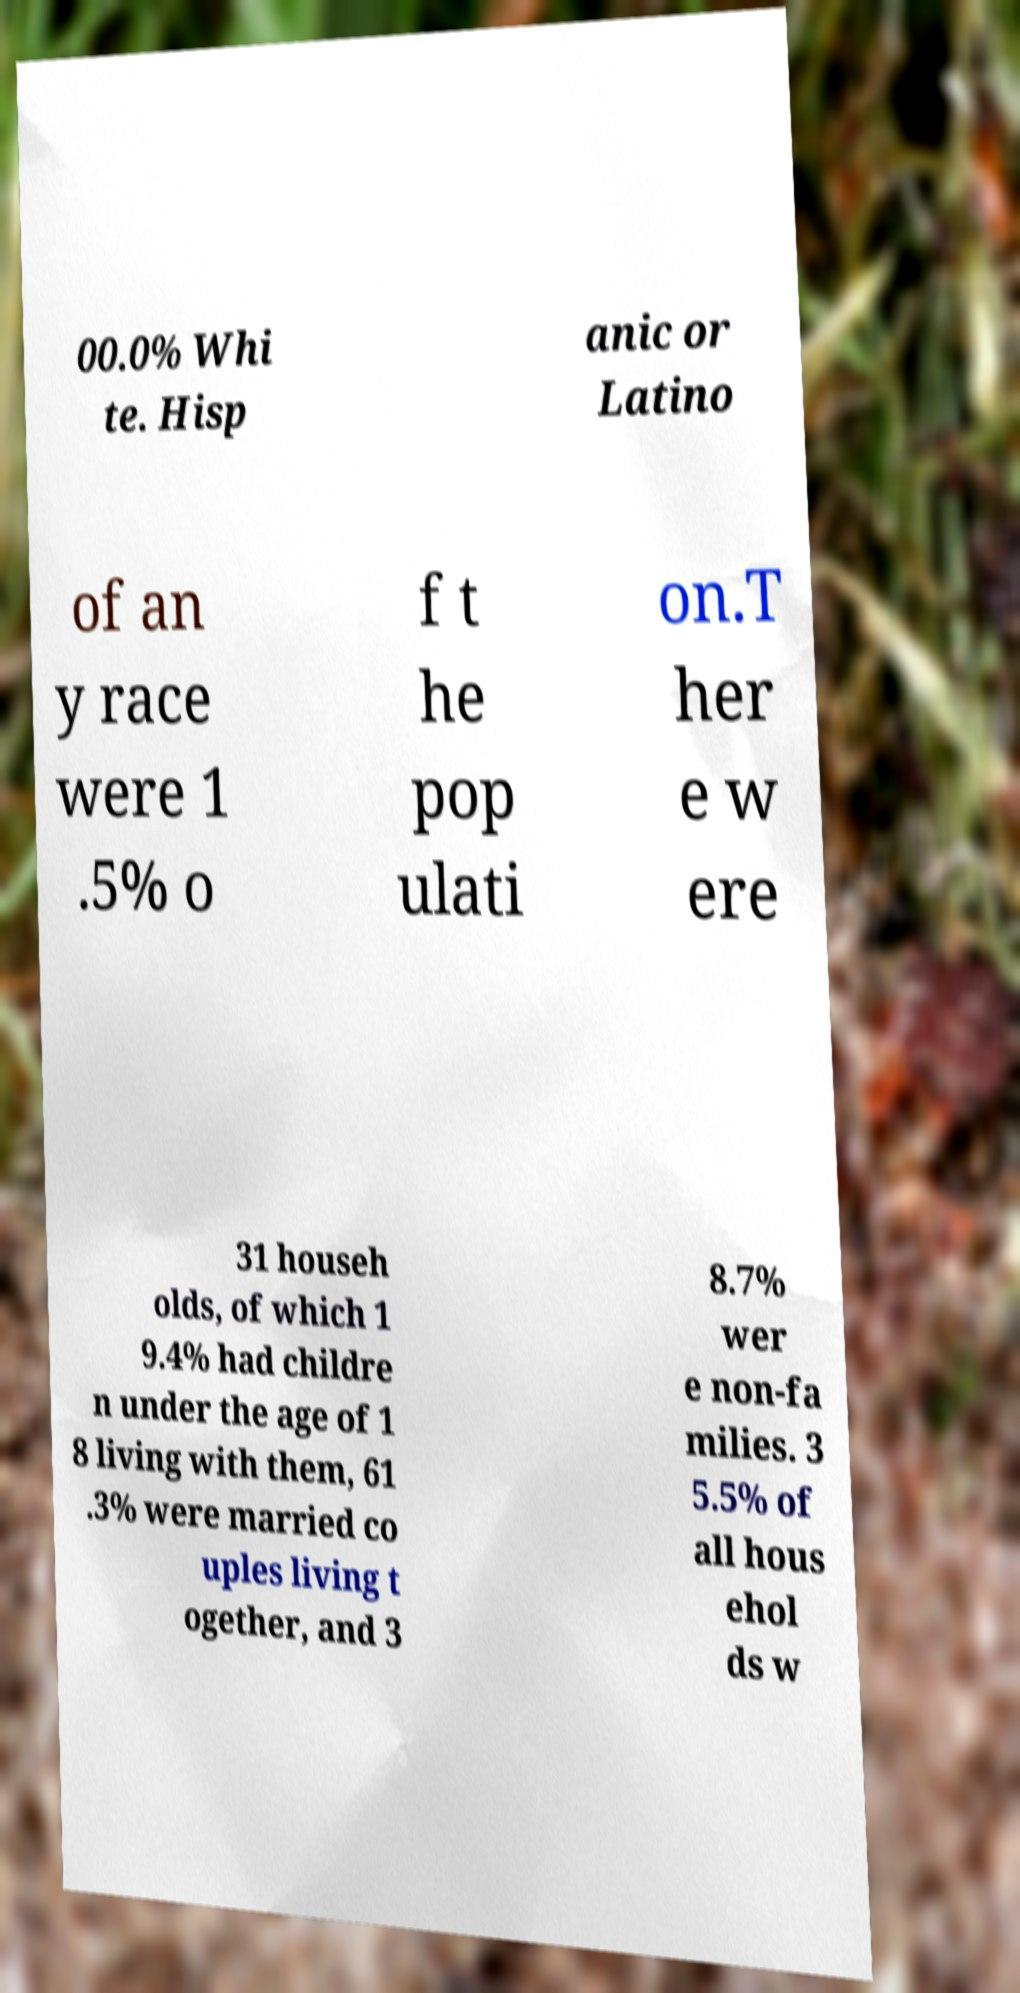What messages or text are displayed in this image? I need them in a readable, typed format. 00.0% Whi te. Hisp anic or Latino of an y race were 1 .5% o f t he pop ulati on.T her e w ere 31 househ olds, of which 1 9.4% had childre n under the age of 1 8 living with them, 61 .3% were married co uples living t ogether, and 3 8.7% wer e non-fa milies. 3 5.5% of all hous ehol ds w 